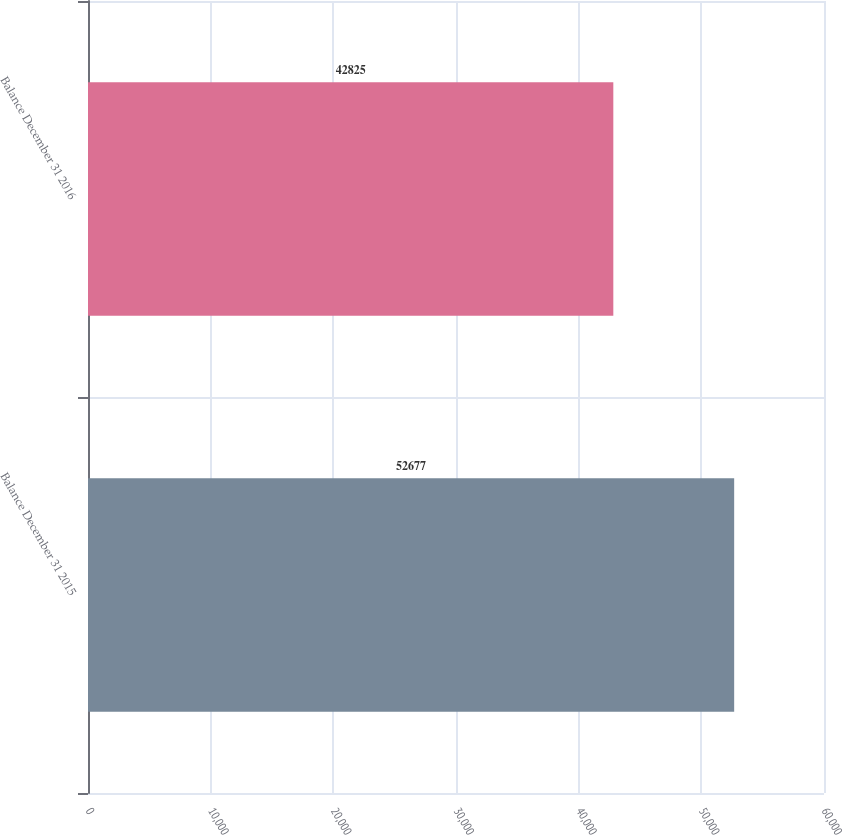<chart> <loc_0><loc_0><loc_500><loc_500><bar_chart><fcel>Balance December 31 2015<fcel>Balance December 31 2016<nl><fcel>52677<fcel>42825<nl></chart> 